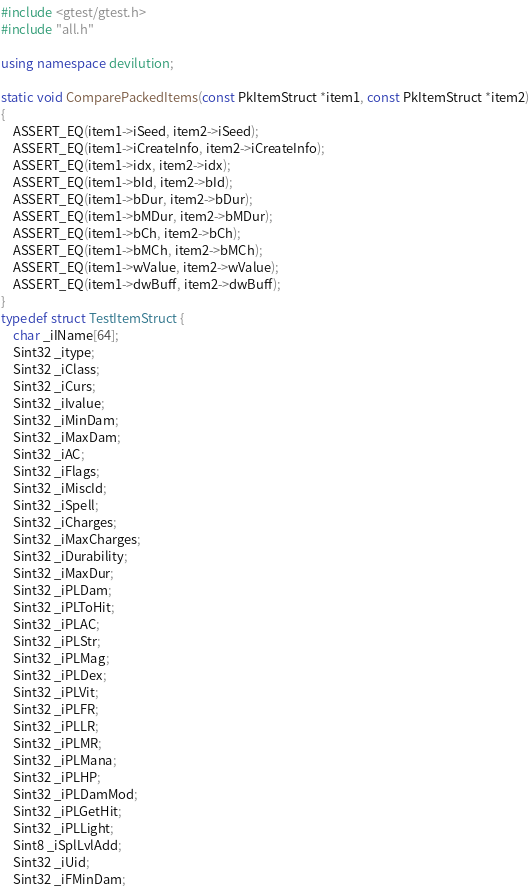Convert code to text. <code><loc_0><loc_0><loc_500><loc_500><_C++_>#include <gtest/gtest.h>
#include "all.h"

using namespace devilution;

static void ComparePackedItems(const PkItemStruct *item1, const PkItemStruct *item2)
{
	ASSERT_EQ(item1->iSeed, item2->iSeed);
	ASSERT_EQ(item1->iCreateInfo, item2->iCreateInfo);
	ASSERT_EQ(item1->idx, item2->idx);
	ASSERT_EQ(item1->bId, item2->bId);
	ASSERT_EQ(item1->bDur, item2->bDur);
	ASSERT_EQ(item1->bMDur, item2->bMDur);
	ASSERT_EQ(item1->bCh, item2->bCh);
	ASSERT_EQ(item1->bMCh, item2->bMCh);
	ASSERT_EQ(item1->wValue, item2->wValue);
	ASSERT_EQ(item1->dwBuff, item2->dwBuff);
}
typedef struct TestItemStruct {
	char _iIName[64];
	Sint32 _itype;
	Sint32 _iClass;
	Sint32 _iCurs;
	Sint32 _iIvalue;
	Sint32 _iMinDam;
	Sint32 _iMaxDam;
	Sint32 _iAC;
	Sint32 _iFlags;
	Sint32 _iMiscId;
	Sint32 _iSpell;
	Sint32 _iCharges;
	Sint32 _iMaxCharges;
	Sint32 _iDurability;
	Sint32 _iMaxDur;
	Sint32 _iPLDam;
	Sint32 _iPLToHit;
	Sint32 _iPLAC;
	Sint32 _iPLStr;
	Sint32 _iPLMag;
	Sint32 _iPLDex;
	Sint32 _iPLVit;
	Sint32 _iPLFR;
	Sint32 _iPLLR;
	Sint32 _iPLMR;
	Sint32 _iPLMana;
	Sint32 _iPLHP;
	Sint32 _iPLDamMod;
	Sint32 _iPLGetHit;
	Sint32 _iPLLight;
	Sint8 _iSplLvlAdd;
	Sint32 _iUid;
	Sint32 _iFMinDam;</code> 